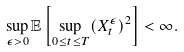Convert formula to latex. <formula><loc_0><loc_0><loc_500><loc_500>\sup _ { \epsilon > 0 } \mathbb { E } \left [ \sup _ { 0 \leq t \leq T } ( X _ { t } ^ { \epsilon } ) ^ { 2 } \right ] < \infty .</formula> 